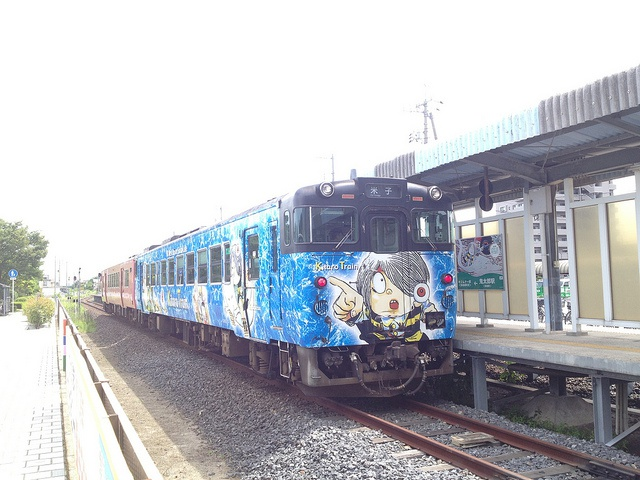Describe the objects in this image and their specific colors. I can see a train in white, gray, lightgray, and darkgray tones in this image. 